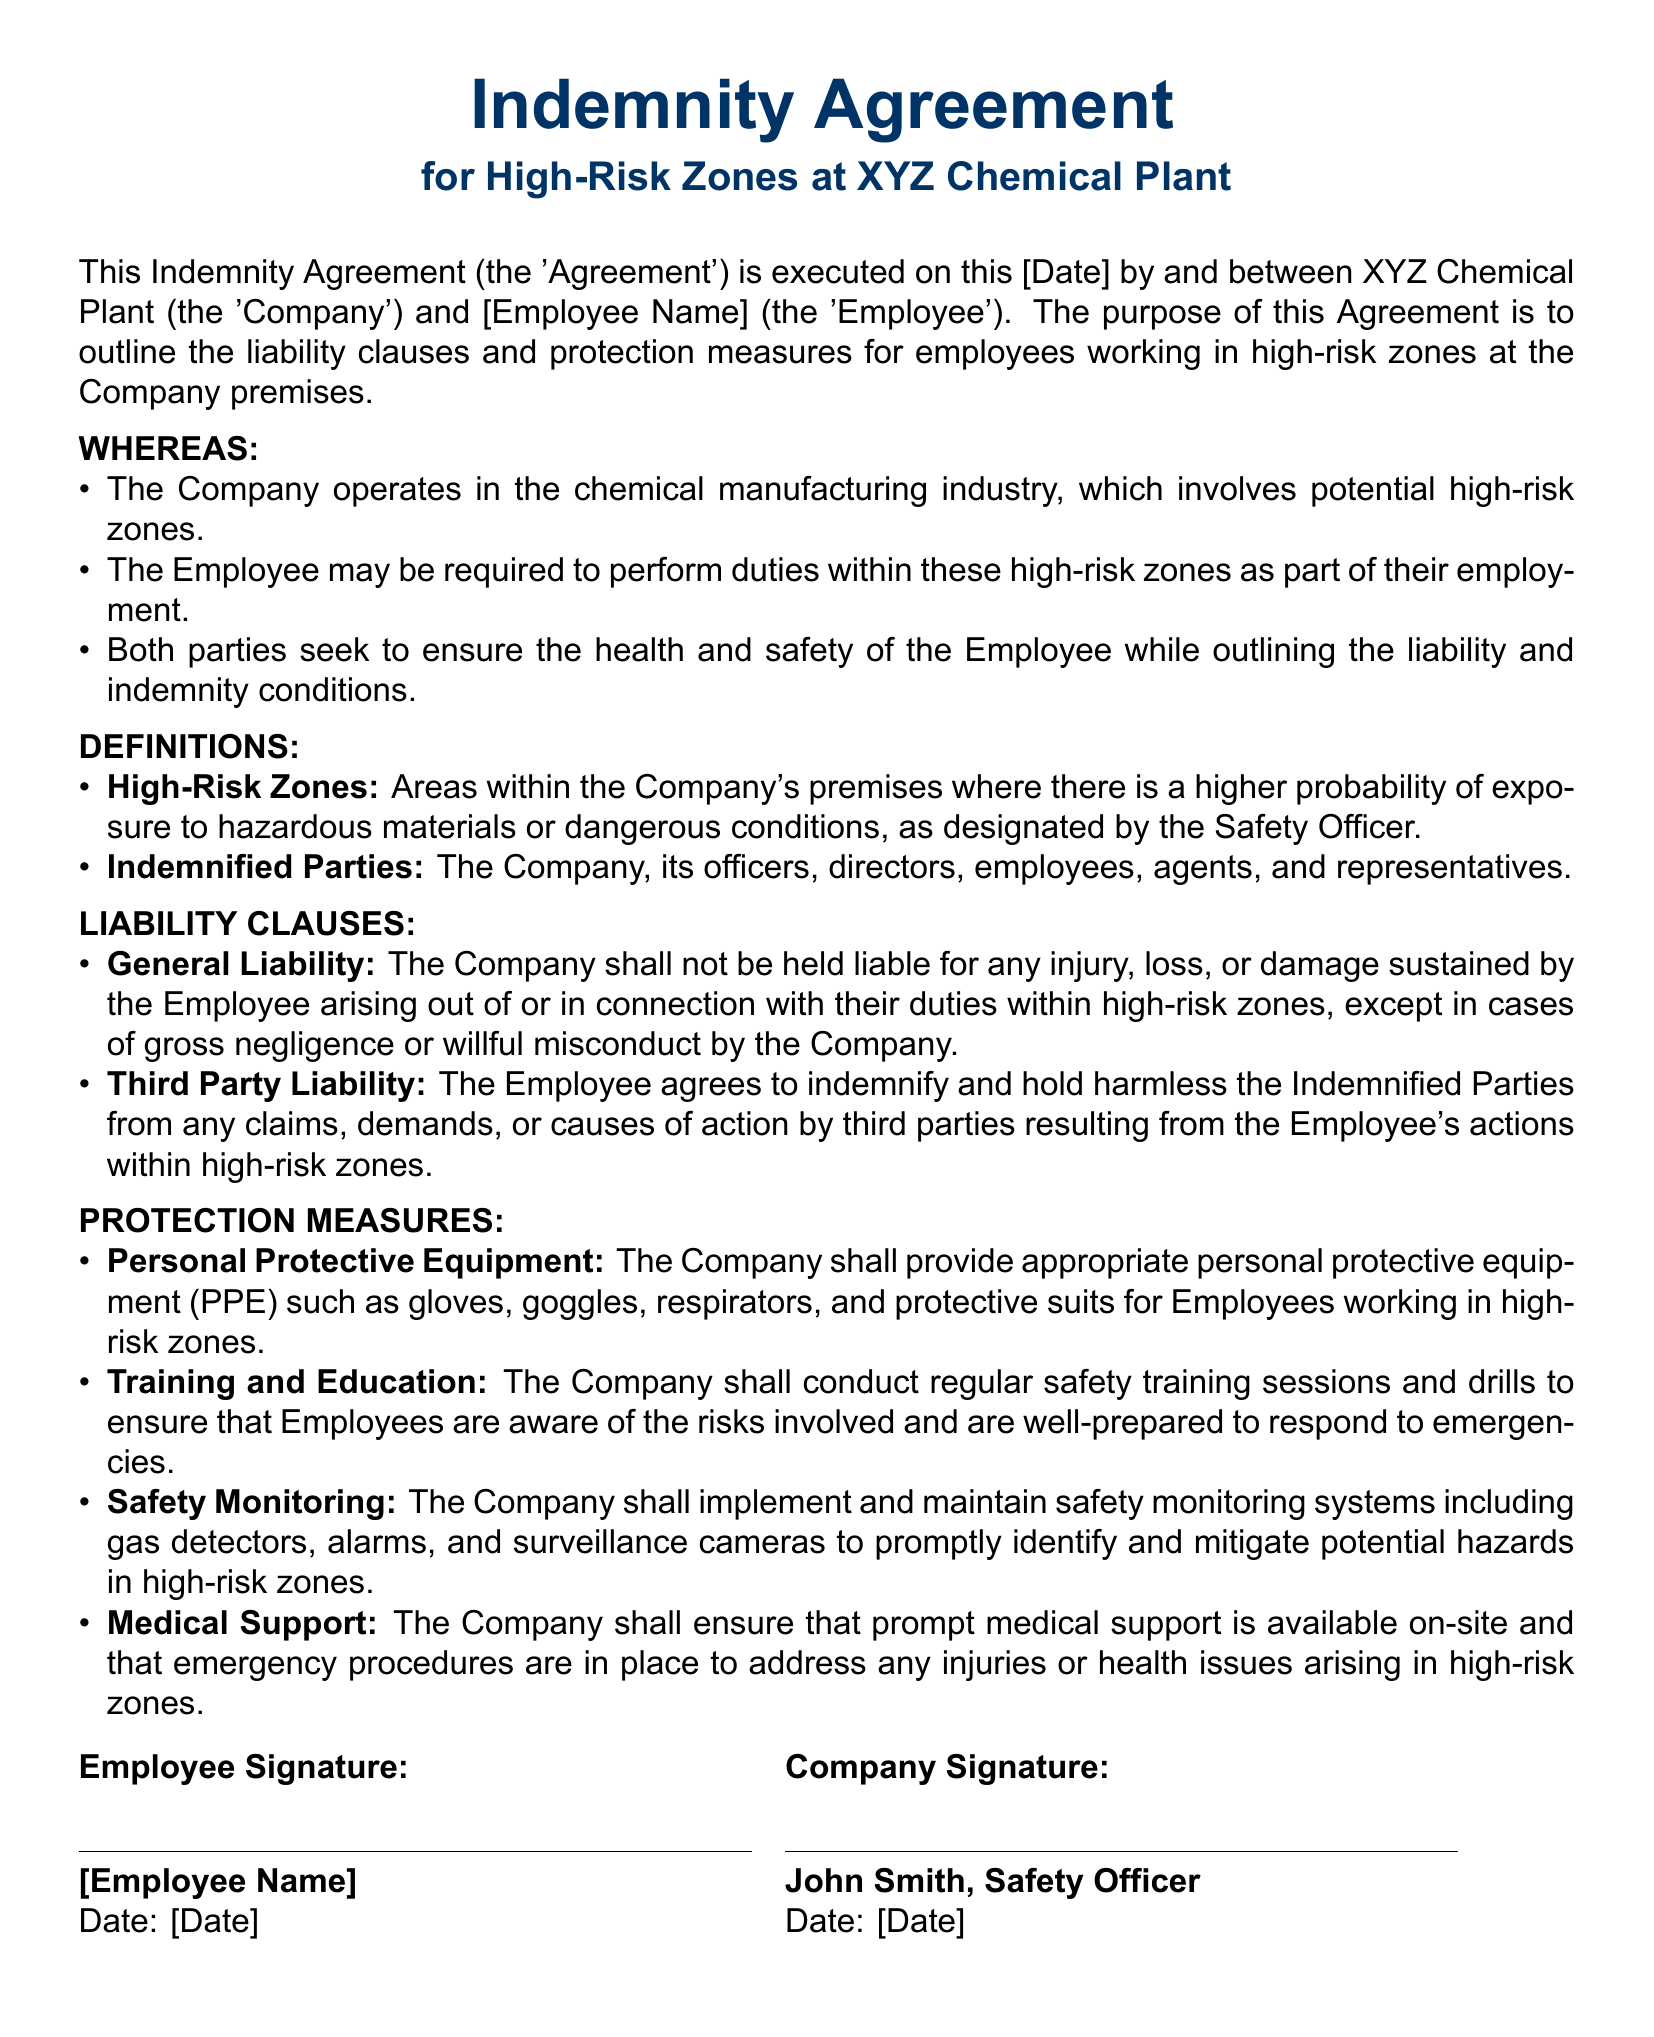What is the title of the document? The title is stated at the beginning of the document.
Answer: Indemnity Agreement What is the name of the company involved? The company is mentioned in the second line of the document.
Answer: XYZ Chemical Plant Who is the designated individual for the company's signature? The document specifies who will sign on behalf of the company.
Answer: John Smith, Safety Officer What equipment will the company provide to employees in high-risk zones? The document lists the categories of equipment provided for safety.
Answer: Personal Protective Equipment What is the primary purpose of this agreement? The document outlines the intent behind creating the agreement.
Answer: To outline the liability clauses and protection measures Under what condition is the company liable for injury? The liability clause specifies exceptions under which the company is liable.
Answer: Gross negligence or willful misconduct What training will be provided to employees? The protection measures include details about training for employees.
Answer: Regular safety training sessions What is the purpose of safety monitoring systems? The document mentions the implementation of safety monitoring.
Answer: To promptly identify and mitigate potential hazards What is meant by "Indemnified Parties"? The document defines who is included as Indemnified Parties.
Answer: The Company, its officers, directors, employees, agents, and representatives What date is required in the document? The document requires dates for signatures at the end.
Answer: Date: [Date] 